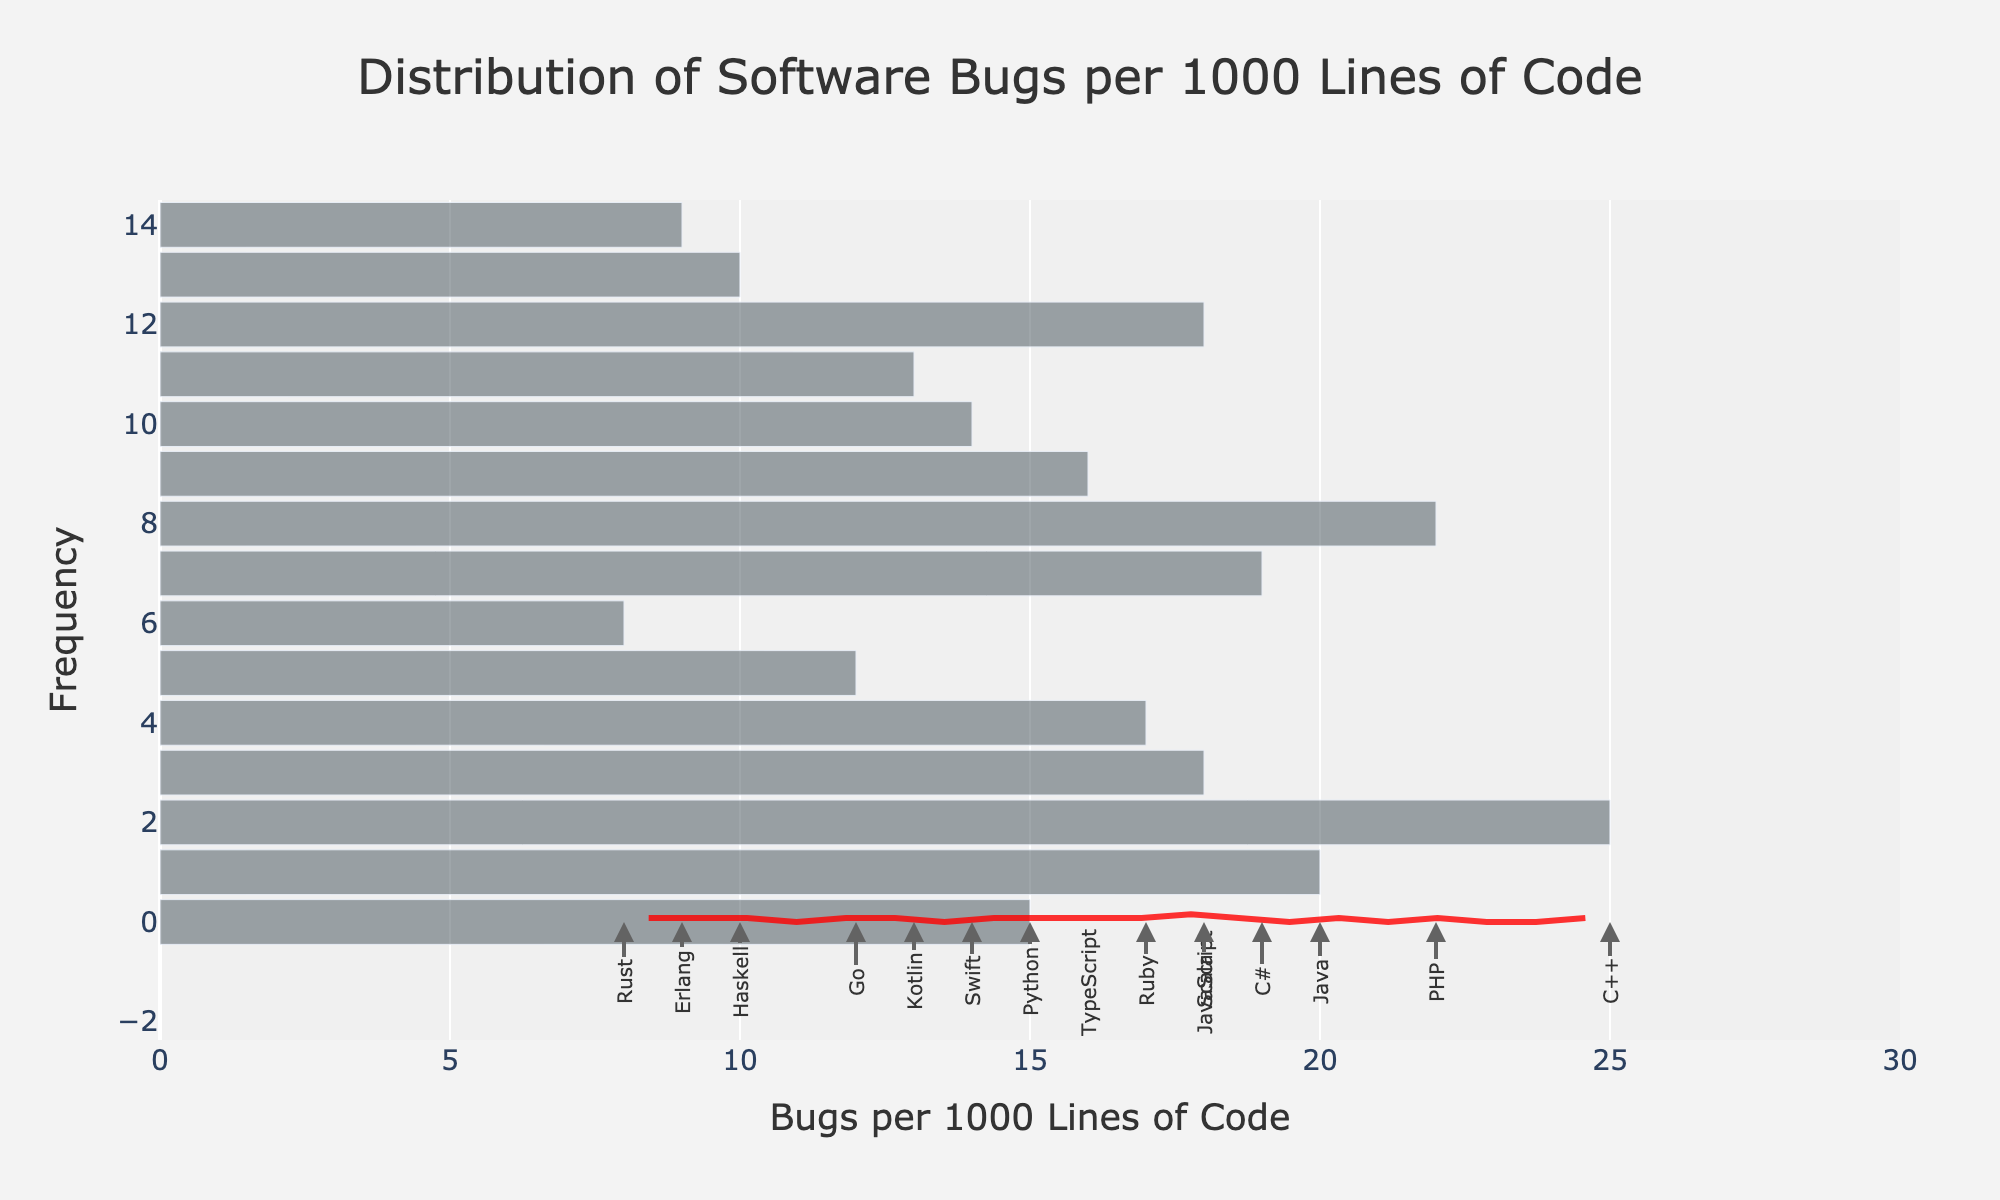What is the title of the figure? The title is usually displayed at the top of the figure. Here, it explicitly states the subject of the data visualization.
Answer: Distribution of Software Bugs per 1000 Lines of Code What is the range of values on the x-axis? The x-axis range can be determined by looking at where the axis starts and ends. Here, it starts at 0 and ends a bit beyond the maximum observed value.
Answer: 0 to 30 How many programming languages are annotated in the figure? The number of programming languages can be counted directly by checking the annotations along the x-axis.
Answer: 15 Which programming language has the lowest number of bugs per 1000 lines of code? Look at the annotations close to 0 on the x-axis and find the language with the smallest value.
Answer: Rust Which programming language is associated with the highest number of bugs per 1000 lines of code? Look at the annotations close to the highest values on the x-axis and find the language with the largest value.
Answer: C++ How does the density curve (KDE) change as the number of bugs per 1000 lines of code increases? The density curve represents the probability density of the data. Observe how it rises, falls, or stays constant as you move along the x-axis.
Answer: It increases initially, peaks, and then decreases What is the most frequent range of bugs per 1000 lines of code observed in the dataset? Find the area under the histogram and KDE curve where the bars are tallest and the density is highest.
Answer: Between 12 and 18 Compare the number of bugs per 1000 lines of code in Python and JavaScript. Which one has more? Locate both Python and JavaScript on the x-axis and compare their positions.
Answer: JavaScript What can you infer about the overall quality of code in Rust compared to PHP based on the figure? Compare the positions of Rust and PHP on the x-axis. Rust is significantly to the left (fewer bugs) compared to PHP, indicating potentially higher code quality.
Answer: Rust has higher code quality What is the average value of bugs per 1000 lines of code for the programming languages in the dataset? Sum up all the values of bugs per 1000 lines of code and divide by the number of programming languages. The values are 15, 20, 25, 18, 17, 12, 8, 19, 22, 16, 14, 13, 18, 10, and 9. The sum is 236. There are 15 programming languages.
Answer: 15.73 